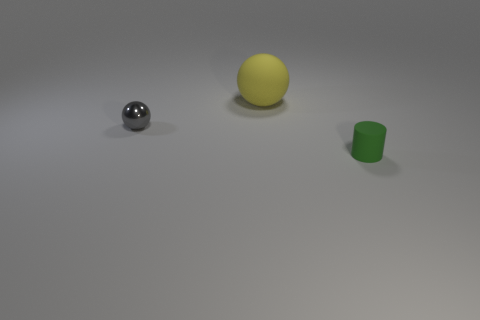Add 1 tiny green objects. How many objects exist? 4 Subtract all gray spheres. How many spheres are left? 1 Subtract all cylinders. How many objects are left? 2 Add 1 purple balls. How many purple balls exist? 1 Subtract 0 blue spheres. How many objects are left? 3 Subtract 1 balls. How many balls are left? 1 Subtract all blue cylinders. Subtract all red blocks. How many cylinders are left? 1 Subtract all purple cubes. How many blue spheres are left? 0 Subtract all tiny spheres. Subtract all matte balls. How many objects are left? 1 Add 2 large yellow rubber spheres. How many large yellow rubber spheres are left? 3 